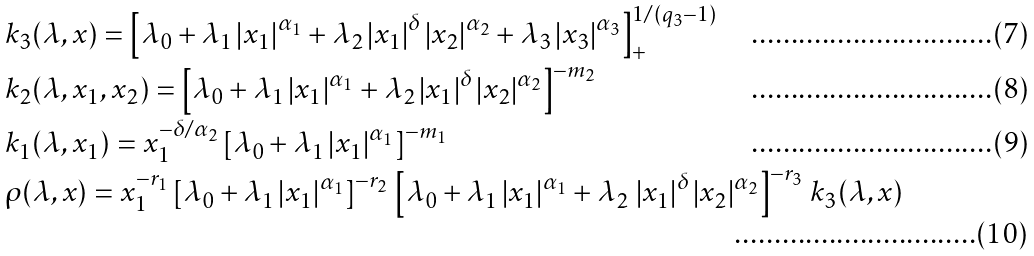Convert formula to latex. <formula><loc_0><loc_0><loc_500><loc_500>& k _ { 3 } ( \lambda , x ) = \left [ \lambda _ { 0 } + \lambda _ { 1 } \left | x _ { 1 } \right | ^ { \alpha _ { 1 } } + \lambda _ { 2 } \left | x _ { 1 } \right | ^ { \delta } \left | x _ { 2 } \right | ^ { \alpha _ { 2 } } + \lambda _ { 3 } \left | x _ { 3 } \right | ^ { \alpha _ { 3 } } \right ] _ { + } ^ { 1 / ( q _ { 3 } - 1 ) } \\ & k _ { 2 } ( \lambda , x _ { 1 } , x _ { 2 } ) = \left [ \lambda _ { 0 } + \lambda _ { 1 } \left | x _ { 1 } \right | ^ { \alpha _ { 1 } } + \lambda _ { 2 } \left | x _ { 1 } \right | ^ { \delta } \left | x _ { 2 } \right | ^ { \alpha _ { 2 } } \right ] ^ { - m _ { 2 } } \\ & k _ { 1 } ( \lambda , x _ { 1 } ) = x _ { 1 } ^ { - \delta / \alpha _ { 2 } } \left [ \lambda _ { 0 } + \lambda _ { 1 } \left | x _ { 1 } \right | ^ { \alpha _ { 1 } } \right ] ^ { - m _ { 1 } } \\ & \rho ( \lambda , x ) = x _ { 1 } ^ { - r _ { 1 } } \left [ \lambda _ { 0 } + \lambda _ { 1 } \left | x _ { 1 } \right | ^ { \alpha _ { 1 } } \right ] ^ { - r _ { 2 } } \, \left [ \lambda _ { 0 } + \lambda _ { 1 } \left | x _ { 1 } \right | ^ { \alpha _ { 1 } } + \lambda _ { 2 } \, \left | x _ { 1 } \right | ^ { \delta } \left | x _ { 2 } \right | ^ { \alpha _ { 2 } } \right ] ^ { - r _ { 3 } } \, k _ { 3 } ( \lambda , x )</formula> 